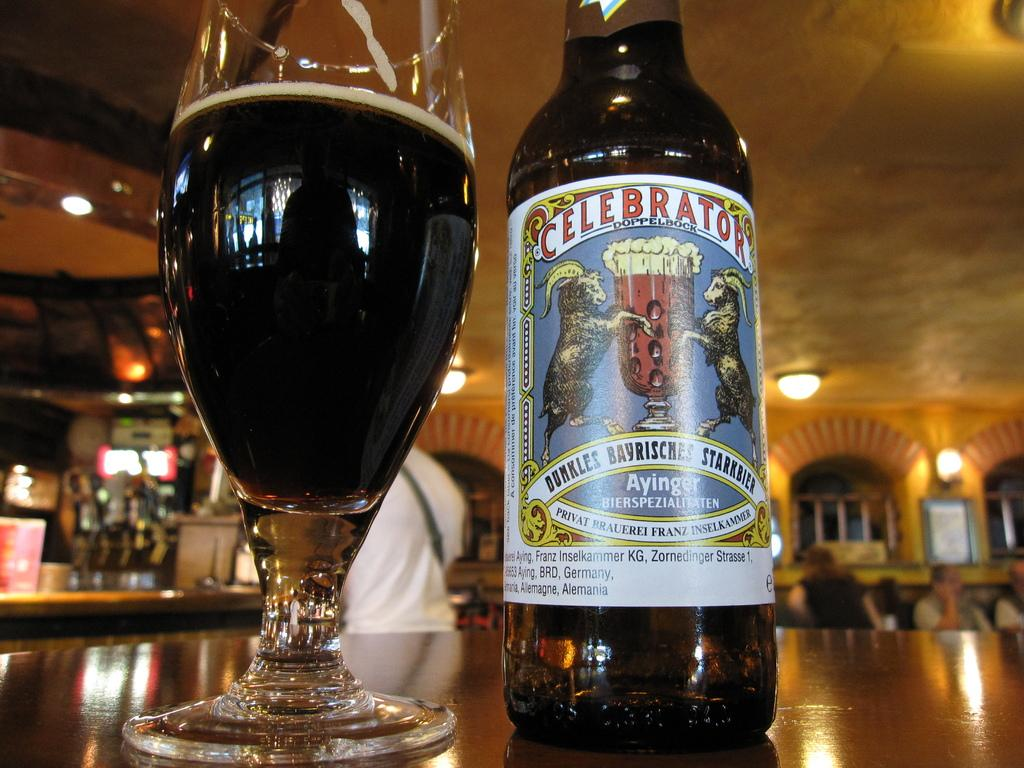<image>
Offer a succinct explanation of the picture presented. A glass of Celebrator beer next to its bottle. 